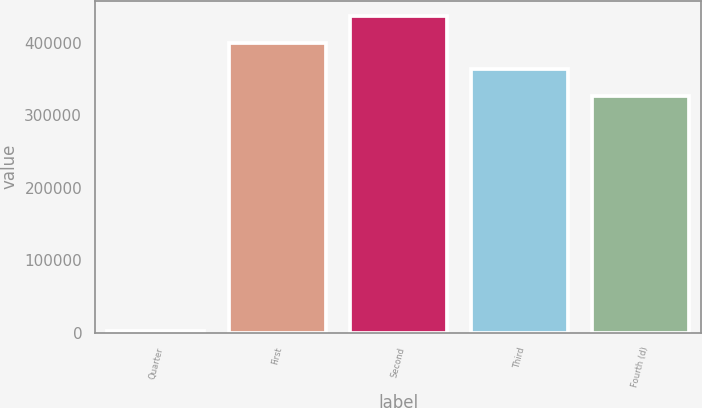Convert chart to OTSL. <chart><loc_0><loc_0><loc_500><loc_500><bar_chart><fcel>Quarter<fcel>First<fcel>Second<fcel>Third<fcel>Fourth (d)<nl><fcel>2016<fcel>399677<fcel>436040<fcel>363314<fcel>326952<nl></chart> 